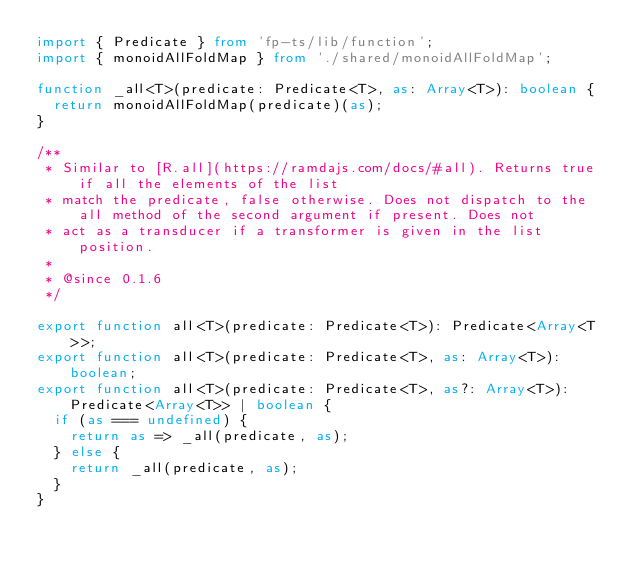Convert code to text. <code><loc_0><loc_0><loc_500><loc_500><_TypeScript_>import { Predicate } from 'fp-ts/lib/function';
import { monoidAllFoldMap } from './shared/monoidAllFoldMap';

function _all<T>(predicate: Predicate<T>, as: Array<T>): boolean {
  return monoidAllFoldMap(predicate)(as);
}

/**
 * Similar to [R.all](https://ramdajs.com/docs/#all). Returns true if all the elements of the list
 * match the predicate, false otherwise. Does not dispatch to the all method of the second argument if present. Does not
 * act as a transducer if a transformer is given in the list position.
 *
 * @since 0.1.6
 */

export function all<T>(predicate: Predicate<T>): Predicate<Array<T>>;
export function all<T>(predicate: Predicate<T>, as: Array<T>): boolean;
export function all<T>(predicate: Predicate<T>, as?: Array<T>): Predicate<Array<T>> | boolean {
  if (as === undefined) {
    return as => _all(predicate, as);
  } else {
    return _all(predicate, as);
  }
}
</code> 